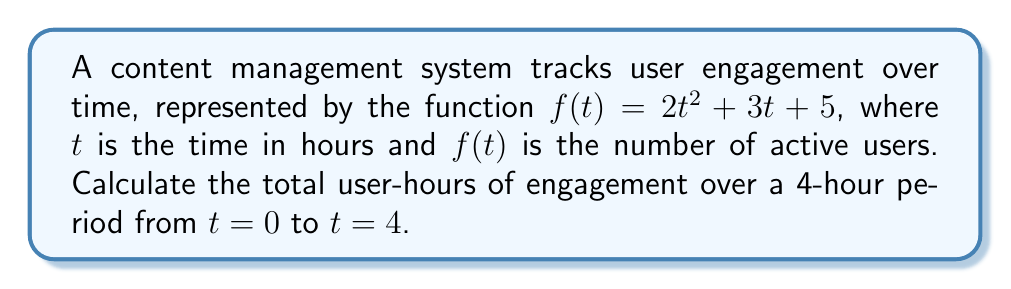Help me with this question. To calculate the total user-hours of engagement, we need to find the area under the curve of $f(t)$ from $t=0$ to $t=4$. This can be done using definite integration.

Step 1: Set up the definite integral
$$\int_0^4 (2t^2 + 3t + 5) dt$$

Step 2: Integrate the function
$$\left[\frac{2t^3}{3} + \frac{3t^2}{2} + 5t\right]_0^4$$

Step 3: Evaluate the integral at the upper and lower bounds
Upper bound: $\frac{2(4^3)}{3} + \frac{3(4^2)}{2} + 5(4) = \frac{128}{3} + 24 + 20$
Lower bound: $\frac{2(0^3)}{3} + \frac{3(0^2)}{2} + 5(0) = 0$

Step 4: Subtract the lower bound from the upper bound
$$\frac{128}{3} + 24 + 20 - 0 = \frac{128}{3} + 44 = \frac{128 + 132}{3} = \frac{260}{3}$$

Step 5: Simplify the result
$$\frac{260}{3} \approx 86.67$$

The total user-hours of engagement over the 4-hour period is approximately 86.67 user-hours.
Answer: $\frac{260}{3}$ user-hours 